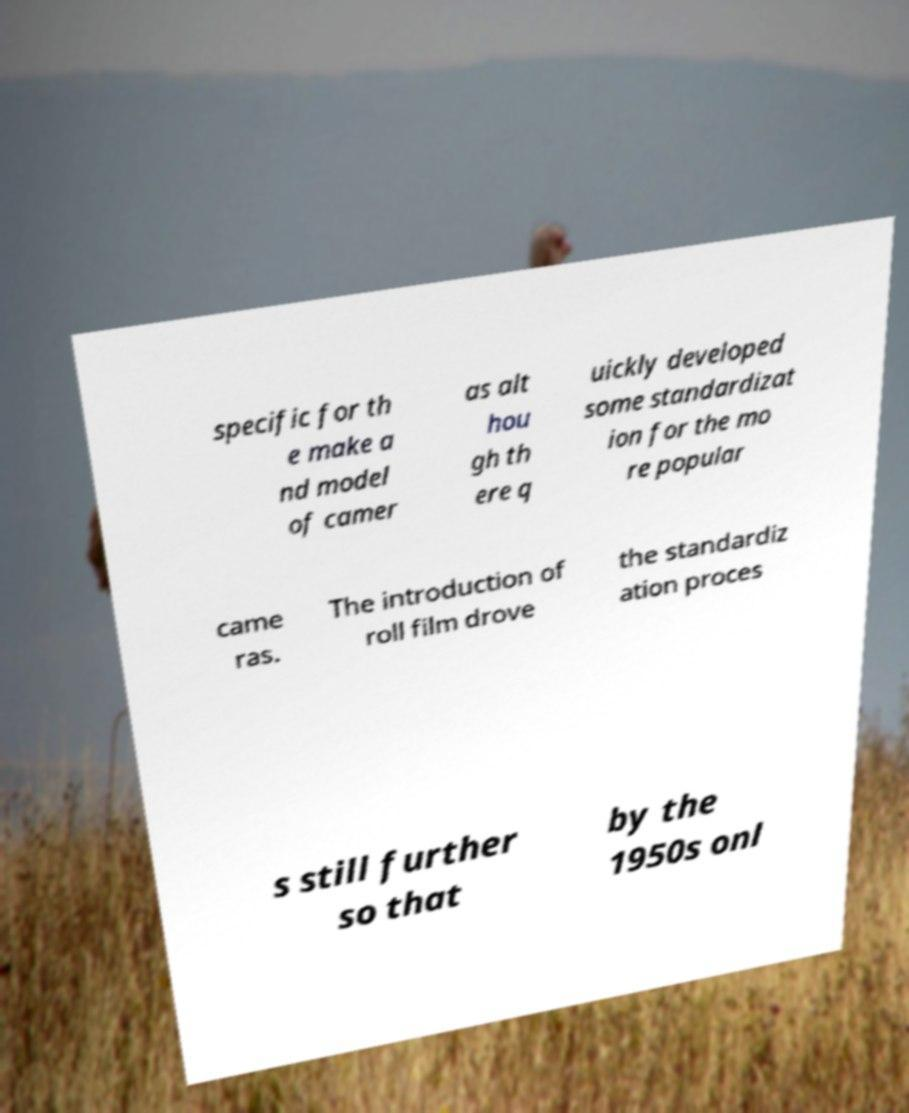Could you assist in decoding the text presented in this image and type it out clearly? specific for th e make a nd model of camer as alt hou gh th ere q uickly developed some standardizat ion for the mo re popular came ras. The introduction of roll film drove the standardiz ation proces s still further so that by the 1950s onl 